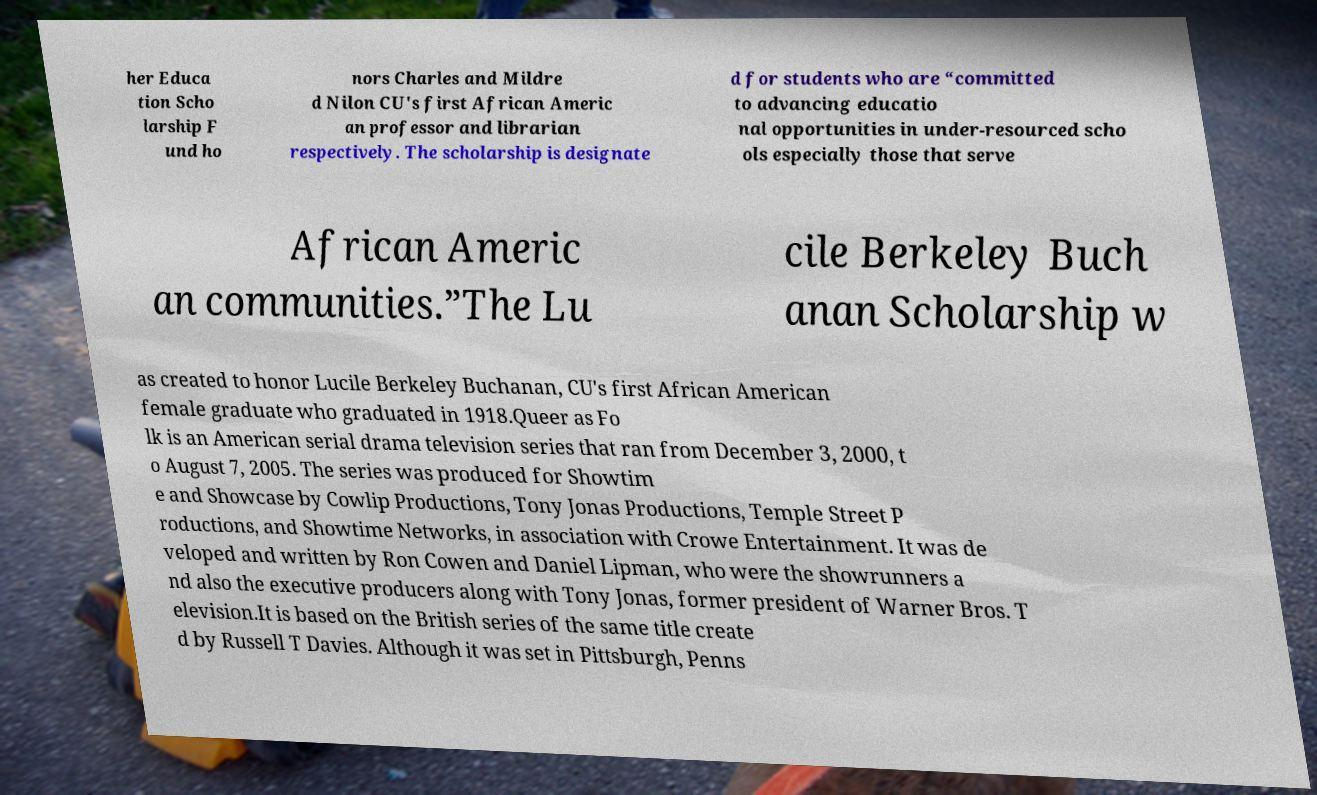Please read and relay the text visible in this image. What does it say? her Educa tion Scho larship F und ho nors Charles and Mildre d Nilon CU's first African Americ an professor and librarian respectively. The scholarship is designate d for students who are “committed to advancing educatio nal opportunities in under-resourced scho ols especially those that serve African Americ an communities.”The Lu cile Berkeley Buch anan Scholarship w as created to honor Lucile Berkeley Buchanan, CU's first African American female graduate who graduated in 1918.Queer as Fo lk is an American serial drama television series that ran from December 3, 2000, t o August 7, 2005. The series was produced for Showtim e and Showcase by Cowlip Productions, Tony Jonas Productions, Temple Street P roductions, and Showtime Networks, in association with Crowe Entertainment. It was de veloped and written by Ron Cowen and Daniel Lipman, who were the showrunners a nd also the executive producers along with Tony Jonas, former president of Warner Bros. T elevision.It is based on the British series of the same title create d by Russell T Davies. Although it was set in Pittsburgh, Penns 